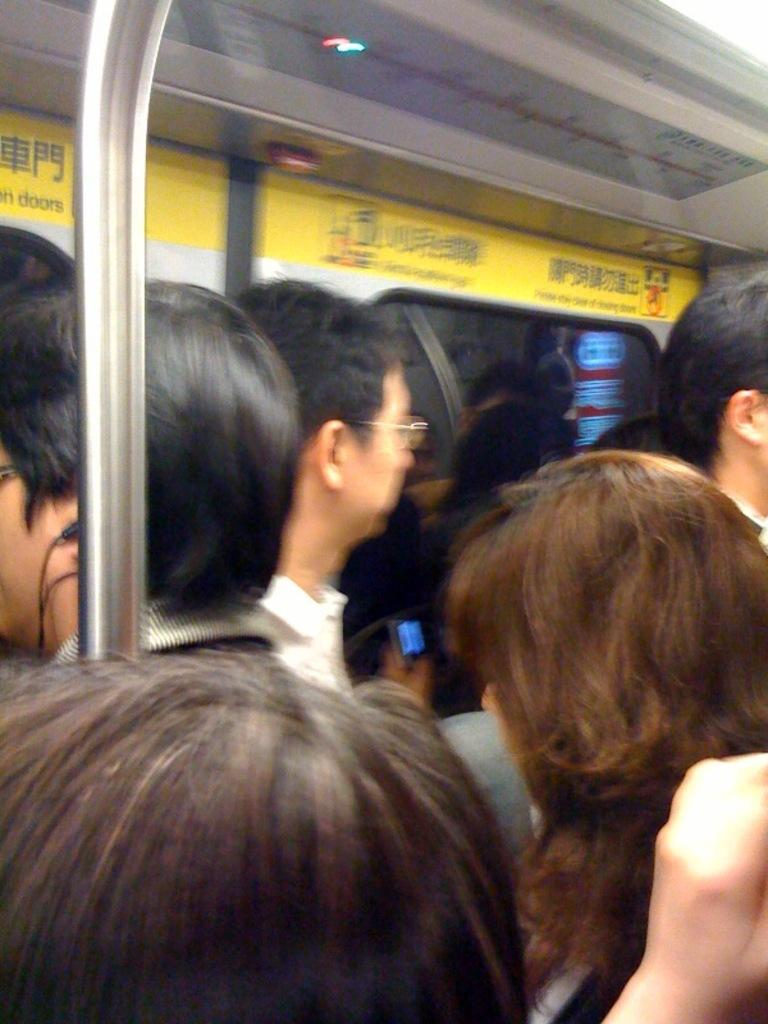How many people are in the image? There is a group of people in the image. Where are the people located in the image? The people are inside a vehicle. What type of eggnog is being served at the club in the image? There is no mention of eggnog or a club in the image; it only features a group of people inside a vehicle. 